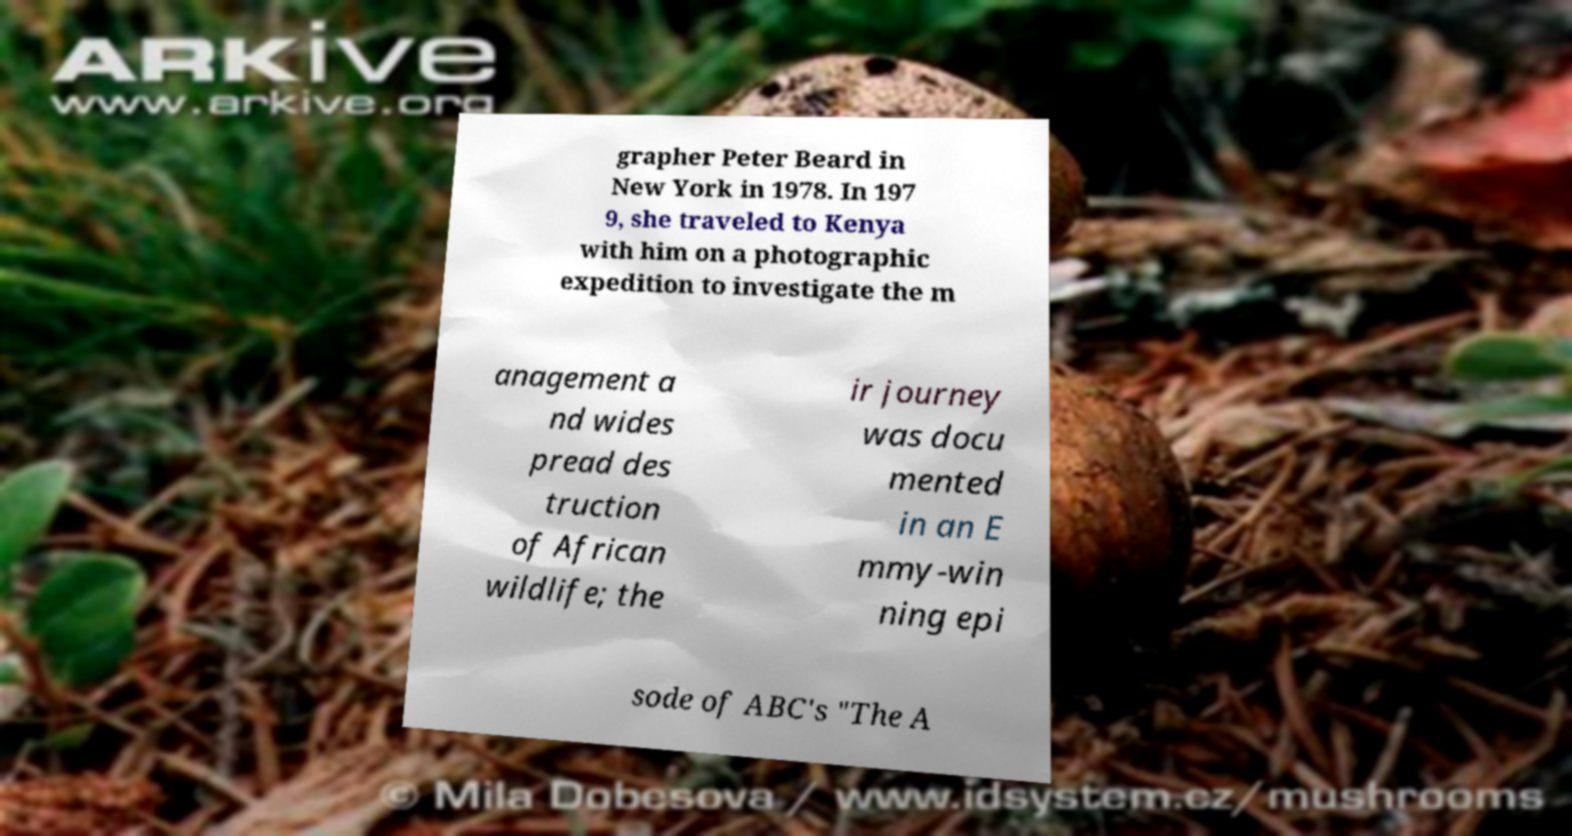There's text embedded in this image that I need extracted. Can you transcribe it verbatim? grapher Peter Beard in New York in 1978. In 197 9, she traveled to Kenya with him on a photographic expedition to investigate the m anagement a nd wides pread des truction of African wildlife; the ir journey was docu mented in an E mmy-win ning epi sode of ABC's "The A 